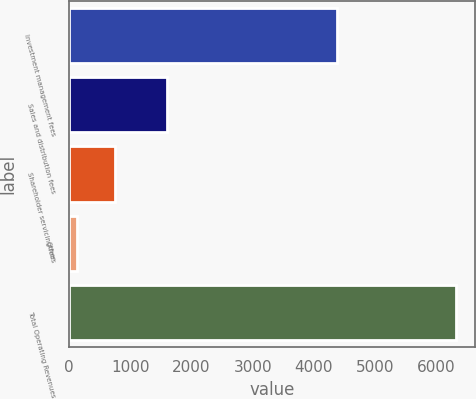<chart> <loc_0><loc_0><loc_500><loc_500><bar_chart><fcel>Investment management fees<fcel>Sales and distribution fees<fcel>Shareholder servicing fees<fcel>Other<fcel>Total Operating Revenues<nl><fcel>4367.5<fcel>1599.8<fcel>748.82<fcel>129.9<fcel>6319.1<nl></chart> 